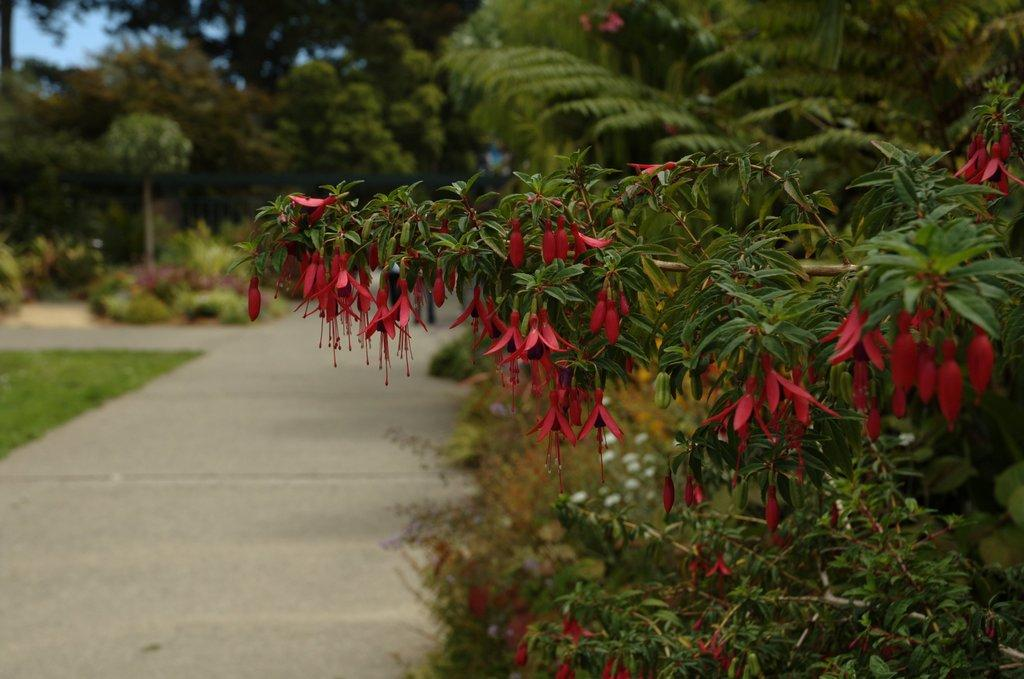What type of plants can be seen in the image? There are plants with flowers in the image. What is the appearance of the background in the image? The background of the image is blurred. What type of vegetation is visible in the foreground of the image? There is grass visible in the image. What can be seen in the background of the image besides the sky? There are plants and trees present in the background of the image. What part of the natural environment is visible in the background of the image? The sky is visible in the background of the image. What type of toy can be seen in the aftermath of the explosion in the image? There is no explosion or toy present in the image. 